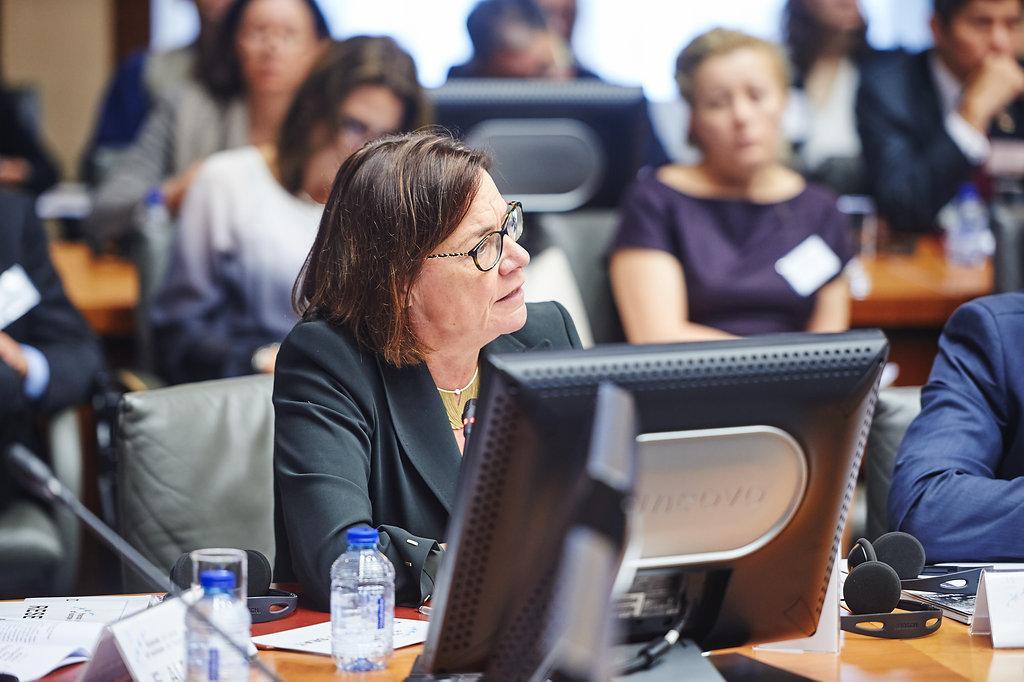Could you give a brief overview of what you see in this image? In this image I can see number of people are sitting on chairs. Here on this table I can see few bottles, a monitor, a mic and a headphone. I can see she is wearing a specs. 